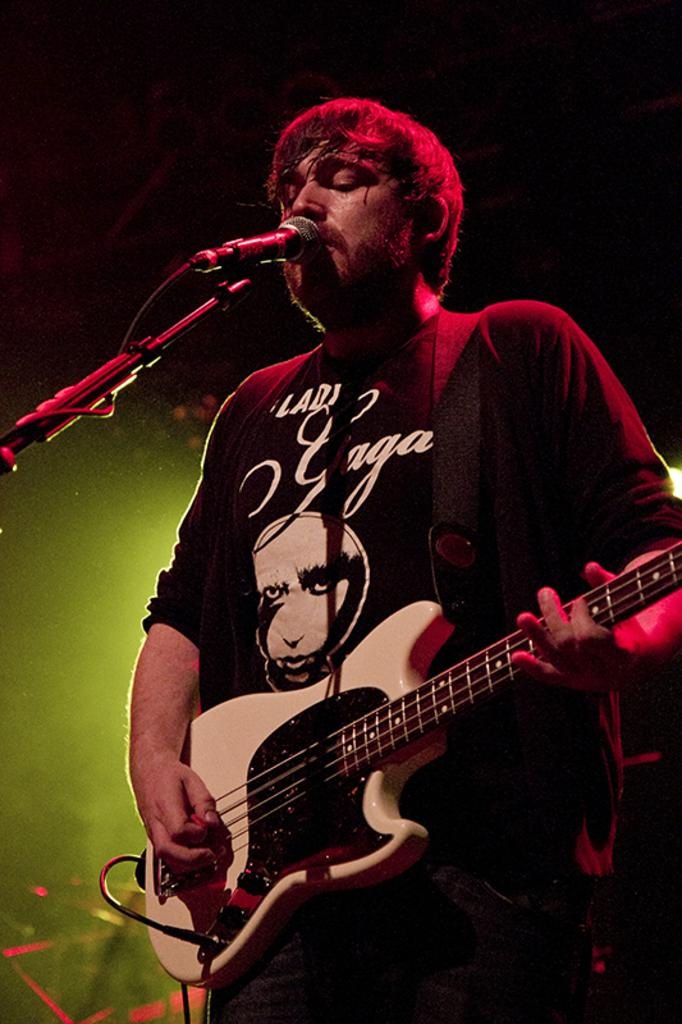Who is the main subject in the image? There is a man in the image. What is the man doing in the image? The man is standing, playing a guitar, and singing into a microphone. What is the man wearing in the image? The man is wearing a black costume. What type of print can be seen on the rabbit's fur in the image? There is no rabbit present in the image, so there is no print on its fur. 